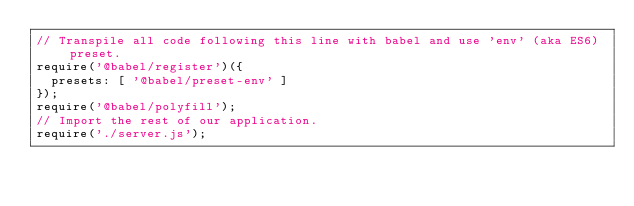<code> <loc_0><loc_0><loc_500><loc_500><_JavaScript_>// Transpile all code following this line with babel and use 'env' (aka ES6) preset.
require('@babel/register')({
  presets: [ '@babel/preset-env' ]
});
require('@babel/polyfill');
// Import the rest of our application.
require('./server.js');</code> 